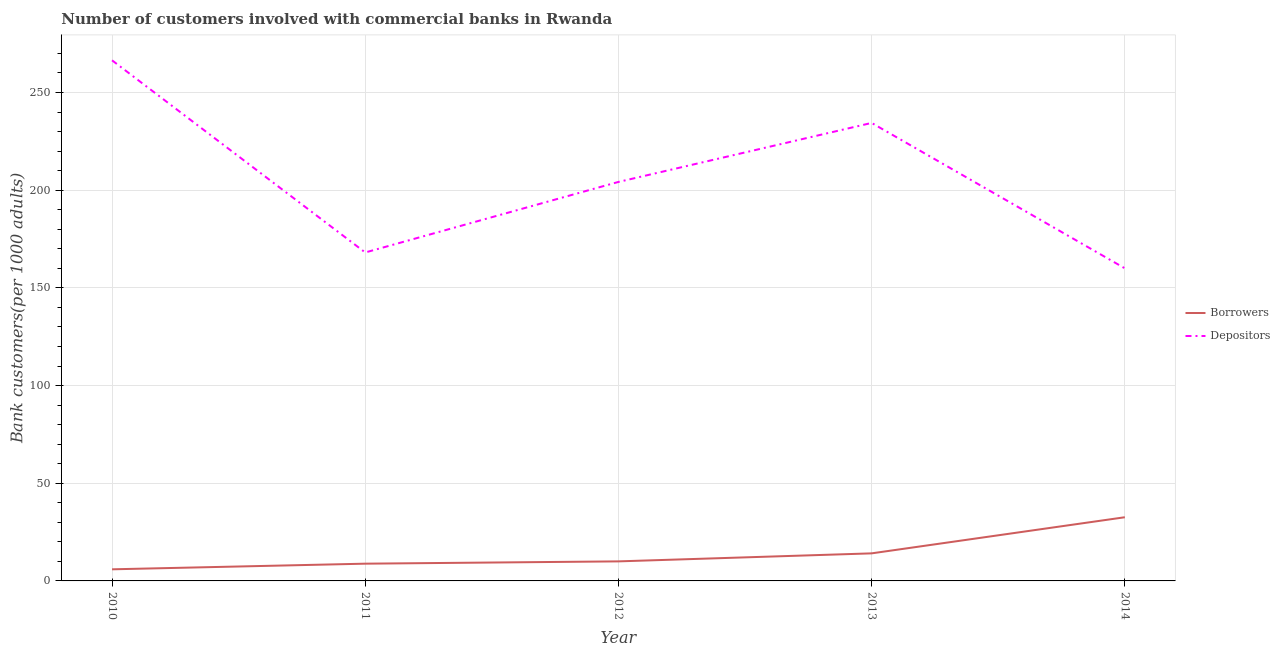What is the number of borrowers in 2010?
Offer a very short reply. 5.94. Across all years, what is the maximum number of borrowers?
Provide a succinct answer. 32.59. Across all years, what is the minimum number of borrowers?
Offer a terse response. 5.94. In which year was the number of depositors minimum?
Keep it short and to the point. 2014. What is the total number of depositors in the graph?
Your answer should be compact. 1033.2. What is the difference between the number of borrowers in 2010 and that in 2012?
Keep it short and to the point. -4.06. What is the difference between the number of borrowers in 2011 and the number of depositors in 2013?
Give a very brief answer. -225.59. What is the average number of borrowers per year?
Offer a terse response. 14.3. In the year 2011, what is the difference between the number of depositors and number of borrowers?
Offer a terse response. 159.28. In how many years, is the number of borrowers greater than 140?
Provide a succinct answer. 0. What is the ratio of the number of borrowers in 2012 to that in 2013?
Provide a succinct answer. 0.71. Is the number of borrowers in 2011 less than that in 2013?
Your answer should be very brief. Yes. Is the difference between the number of borrowers in 2012 and 2013 greater than the difference between the number of depositors in 2012 and 2013?
Keep it short and to the point. Yes. What is the difference between the highest and the second highest number of depositors?
Your answer should be very brief. 32.04. What is the difference between the highest and the lowest number of depositors?
Your answer should be very brief. 106.45. In how many years, is the number of depositors greater than the average number of depositors taken over all years?
Provide a short and direct response. 2. Does the number of depositors monotonically increase over the years?
Your response must be concise. No. Is the number of borrowers strictly greater than the number of depositors over the years?
Your answer should be compact. No. Is the number of depositors strictly less than the number of borrowers over the years?
Offer a very short reply. No. What is the difference between two consecutive major ticks on the Y-axis?
Your answer should be very brief. 50. How many legend labels are there?
Offer a terse response. 2. What is the title of the graph?
Give a very brief answer. Number of customers involved with commercial banks in Rwanda. Does "Current US$" appear as one of the legend labels in the graph?
Keep it short and to the point. No. What is the label or title of the X-axis?
Provide a succinct answer. Year. What is the label or title of the Y-axis?
Ensure brevity in your answer.  Bank customers(per 1000 adults). What is the Bank customers(per 1000 adults) in Borrowers in 2010?
Provide a short and direct response. 5.94. What is the Bank customers(per 1000 adults) of Depositors in 2010?
Your answer should be compact. 266.46. What is the Bank customers(per 1000 adults) in Borrowers in 2011?
Provide a succinct answer. 8.83. What is the Bank customers(per 1000 adults) in Depositors in 2011?
Make the answer very short. 168.11. What is the Bank customers(per 1000 adults) of Borrowers in 2012?
Provide a short and direct response. 10. What is the Bank customers(per 1000 adults) in Depositors in 2012?
Offer a very short reply. 204.22. What is the Bank customers(per 1000 adults) in Borrowers in 2013?
Offer a terse response. 14.11. What is the Bank customers(per 1000 adults) of Depositors in 2013?
Ensure brevity in your answer.  234.42. What is the Bank customers(per 1000 adults) in Borrowers in 2014?
Make the answer very short. 32.59. What is the Bank customers(per 1000 adults) of Depositors in 2014?
Keep it short and to the point. 160. Across all years, what is the maximum Bank customers(per 1000 adults) in Borrowers?
Make the answer very short. 32.59. Across all years, what is the maximum Bank customers(per 1000 adults) of Depositors?
Keep it short and to the point. 266.46. Across all years, what is the minimum Bank customers(per 1000 adults) of Borrowers?
Your answer should be compact. 5.94. Across all years, what is the minimum Bank customers(per 1000 adults) of Depositors?
Offer a very short reply. 160. What is the total Bank customers(per 1000 adults) in Borrowers in the graph?
Offer a very short reply. 71.48. What is the total Bank customers(per 1000 adults) in Depositors in the graph?
Your response must be concise. 1033.2. What is the difference between the Bank customers(per 1000 adults) of Borrowers in 2010 and that in 2011?
Give a very brief answer. -2.89. What is the difference between the Bank customers(per 1000 adults) of Depositors in 2010 and that in 2011?
Your response must be concise. 98.35. What is the difference between the Bank customers(per 1000 adults) of Borrowers in 2010 and that in 2012?
Offer a very short reply. -4.06. What is the difference between the Bank customers(per 1000 adults) in Depositors in 2010 and that in 2012?
Your answer should be compact. 62.24. What is the difference between the Bank customers(per 1000 adults) in Borrowers in 2010 and that in 2013?
Offer a terse response. -8.17. What is the difference between the Bank customers(per 1000 adults) in Depositors in 2010 and that in 2013?
Keep it short and to the point. 32.04. What is the difference between the Bank customers(per 1000 adults) of Borrowers in 2010 and that in 2014?
Offer a very short reply. -26.65. What is the difference between the Bank customers(per 1000 adults) in Depositors in 2010 and that in 2014?
Your response must be concise. 106.45. What is the difference between the Bank customers(per 1000 adults) of Borrowers in 2011 and that in 2012?
Ensure brevity in your answer.  -1.17. What is the difference between the Bank customers(per 1000 adults) of Depositors in 2011 and that in 2012?
Give a very brief answer. -36.1. What is the difference between the Bank customers(per 1000 adults) of Borrowers in 2011 and that in 2013?
Your answer should be very brief. -5.28. What is the difference between the Bank customers(per 1000 adults) in Depositors in 2011 and that in 2013?
Offer a very short reply. -66.31. What is the difference between the Bank customers(per 1000 adults) of Borrowers in 2011 and that in 2014?
Offer a terse response. -23.76. What is the difference between the Bank customers(per 1000 adults) in Depositors in 2011 and that in 2014?
Make the answer very short. 8.11. What is the difference between the Bank customers(per 1000 adults) in Borrowers in 2012 and that in 2013?
Offer a very short reply. -4.11. What is the difference between the Bank customers(per 1000 adults) in Depositors in 2012 and that in 2013?
Provide a short and direct response. -30.2. What is the difference between the Bank customers(per 1000 adults) in Borrowers in 2012 and that in 2014?
Keep it short and to the point. -22.59. What is the difference between the Bank customers(per 1000 adults) of Depositors in 2012 and that in 2014?
Provide a short and direct response. 44.21. What is the difference between the Bank customers(per 1000 adults) of Borrowers in 2013 and that in 2014?
Your answer should be very brief. -18.48. What is the difference between the Bank customers(per 1000 adults) in Depositors in 2013 and that in 2014?
Provide a succinct answer. 74.41. What is the difference between the Bank customers(per 1000 adults) in Borrowers in 2010 and the Bank customers(per 1000 adults) in Depositors in 2011?
Your response must be concise. -162.17. What is the difference between the Bank customers(per 1000 adults) of Borrowers in 2010 and the Bank customers(per 1000 adults) of Depositors in 2012?
Your answer should be very brief. -198.27. What is the difference between the Bank customers(per 1000 adults) in Borrowers in 2010 and the Bank customers(per 1000 adults) in Depositors in 2013?
Your response must be concise. -228.47. What is the difference between the Bank customers(per 1000 adults) in Borrowers in 2010 and the Bank customers(per 1000 adults) in Depositors in 2014?
Provide a succinct answer. -154.06. What is the difference between the Bank customers(per 1000 adults) of Borrowers in 2011 and the Bank customers(per 1000 adults) of Depositors in 2012?
Offer a very short reply. -195.39. What is the difference between the Bank customers(per 1000 adults) of Borrowers in 2011 and the Bank customers(per 1000 adults) of Depositors in 2013?
Offer a very short reply. -225.59. What is the difference between the Bank customers(per 1000 adults) in Borrowers in 2011 and the Bank customers(per 1000 adults) in Depositors in 2014?
Keep it short and to the point. -151.17. What is the difference between the Bank customers(per 1000 adults) in Borrowers in 2012 and the Bank customers(per 1000 adults) in Depositors in 2013?
Your response must be concise. -224.42. What is the difference between the Bank customers(per 1000 adults) in Borrowers in 2012 and the Bank customers(per 1000 adults) in Depositors in 2014?
Offer a very short reply. -150. What is the difference between the Bank customers(per 1000 adults) in Borrowers in 2013 and the Bank customers(per 1000 adults) in Depositors in 2014?
Your answer should be compact. -145.89. What is the average Bank customers(per 1000 adults) of Borrowers per year?
Give a very brief answer. 14.3. What is the average Bank customers(per 1000 adults) of Depositors per year?
Keep it short and to the point. 206.64. In the year 2010, what is the difference between the Bank customers(per 1000 adults) in Borrowers and Bank customers(per 1000 adults) in Depositors?
Your response must be concise. -260.51. In the year 2011, what is the difference between the Bank customers(per 1000 adults) of Borrowers and Bank customers(per 1000 adults) of Depositors?
Make the answer very short. -159.28. In the year 2012, what is the difference between the Bank customers(per 1000 adults) in Borrowers and Bank customers(per 1000 adults) in Depositors?
Ensure brevity in your answer.  -194.21. In the year 2013, what is the difference between the Bank customers(per 1000 adults) in Borrowers and Bank customers(per 1000 adults) in Depositors?
Your answer should be very brief. -220.31. In the year 2014, what is the difference between the Bank customers(per 1000 adults) of Borrowers and Bank customers(per 1000 adults) of Depositors?
Offer a terse response. -127.41. What is the ratio of the Bank customers(per 1000 adults) in Borrowers in 2010 to that in 2011?
Provide a short and direct response. 0.67. What is the ratio of the Bank customers(per 1000 adults) of Depositors in 2010 to that in 2011?
Make the answer very short. 1.58. What is the ratio of the Bank customers(per 1000 adults) in Borrowers in 2010 to that in 2012?
Keep it short and to the point. 0.59. What is the ratio of the Bank customers(per 1000 adults) of Depositors in 2010 to that in 2012?
Your answer should be very brief. 1.3. What is the ratio of the Bank customers(per 1000 adults) in Borrowers in 2010 to that in 2013?
Give a very brief answer. 0.42. What is the ratio of the Bank customers(per 1000 adults) of Depositors in 2010 to that in 2013?
Give a very brief answer. 1.14. What is the ratio of the Bank customers(per 1000 adults) of Borrowers in 2010 to that in 2014?
Ensure brevity in your answer.  0.18. What is the ratio of the Bank customers(per 1000 adults) in Depositors in 2010 to that in 2014?
Keep it short and to the point. 1.67. What is the ratio of the Bank customers(per 1000 adults) of Borrowers in 2011 to that in 2012?
Provide a short and direct response. 0.88. What is the ratio of the Bank customers(per 1000 adults) of Depositors in 2011 to that in 2012?
Your answer should be very brief. 0.82. What is the ratio of the Bank customers(per 1000 adults) in Borrowers in 2011 to that in 2013?
Ensure brevity in your answer.  0.63. What is the ratio of the Bank customers(per 1000 adults) of Depositors in 2011 to that in 2013?
Provide a short and direct response. 0.72. What is the ratio of the Bank customers(per 1000 adults) of Borrowers in 2011 to that in 2014?
Provide a succinct answer. 0.27. What is the ratio of the Bank customers(per 1000 adults) of Depositors in 2011 to that in 2014?
Keep it short and to the point. 1.05. What is the ratio of the Bank customers(per 1000 adults) in Borrowers in 2012 to that in 2013?
Provide a succinct answer. 0.71. What is the ratio of the Bank customers(per 1000 adults) in Depositors in 2012 to that in 2013?
Offer a very short reply. 0.87. What is the ratio of the Bank customers(per 1000 adults) of Borrowers in 2012 to that in 2014?
Give a very brief answer. 0.31. What is the ratio of the Bank customers(per 1000 adults) in Depositors in 2012 to that in 2014?
Your answer should be compact. 1.28. What is the ratio of the Bank customers(per 1000 adults) in Borrowers in 2013 to that in 2014?
Your answer should be very brief. 0.43. What is the ratio of the Bank customers(per 1000 adults) in Depositors in 2013 to that in 2014?
Your answer should be compact. 1.47. What is the difference between the highest and the second highest Bank customers(per 1000 adults) in Borrowers?
Make the answer very short. 18.48. What is the difference between the highest and the second highest Bank customers(per 1000 adults) in Depositors?
Give a very brief answer. 32.04. What is the difference between the highest and the lowest Bank customers(per 1000 adults) of Borrowers?
Provide a succinct answer. 26.65. What is the difference between the highest and the lowest Bank customers(per 1000 adults) of Depositors?
Provide a short and direct response. 106.45. 